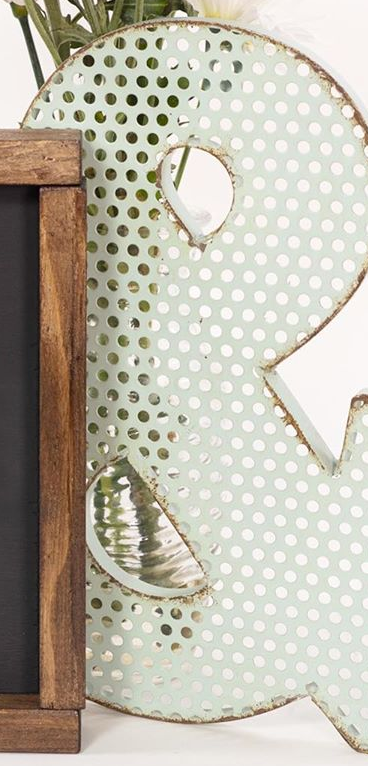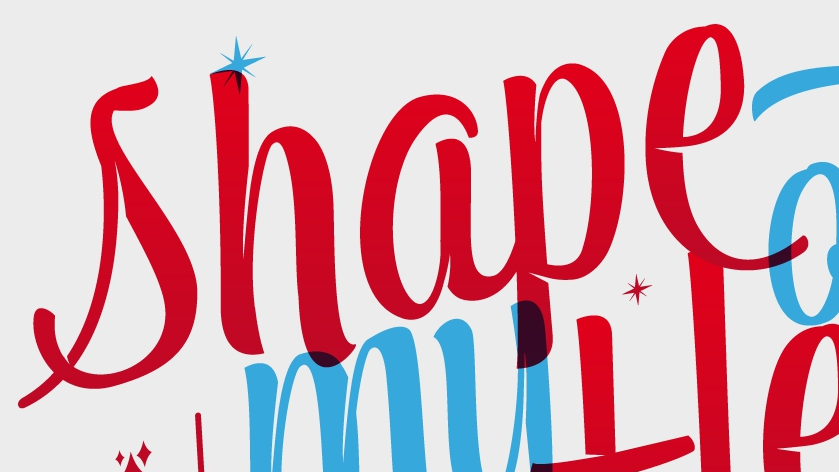What words can you see in these images in sequence, separated by a semicolon? &; shape 